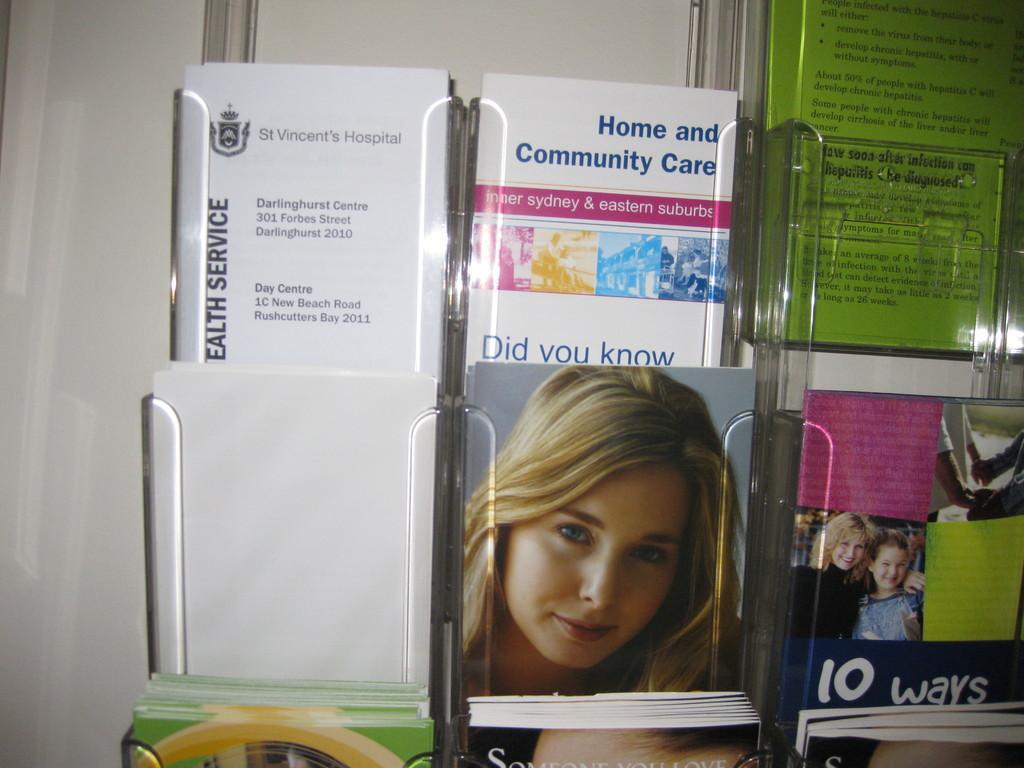Can you describe this image briefly? In the picture I can see books on a glass object. On these books covers I can see photos of people and something written on them. 